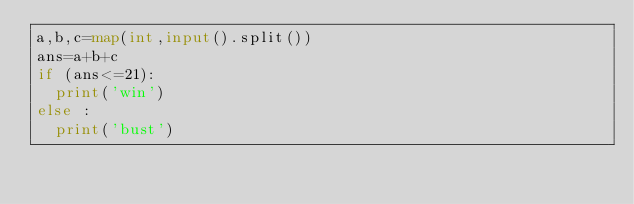<code> <loc_0><loc_0><loc_500><loc_500><_Python_>a,b,c=map(int,input().split())
ans=a+b+c
if (ans<=21):
  print('win')
else :
  print('bust')</code> 